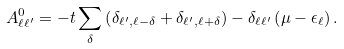<formula> <loc_0><loc_0><loc_500><loc_500>A ^ { 0 } _ { \ell \ell ^ { \prime } } = - t \sum _ { \delta } \left ( \delta _ { \ell ^ { \prime } , \ell - \delta } + \delta _ { \ell ^ { \prime } , \ell + \delta } \right ) - \delta _ { \ell \ell ^ { \prime } } \left ( \mu - \epsilon _ { \ell } \right ) .</formula> 